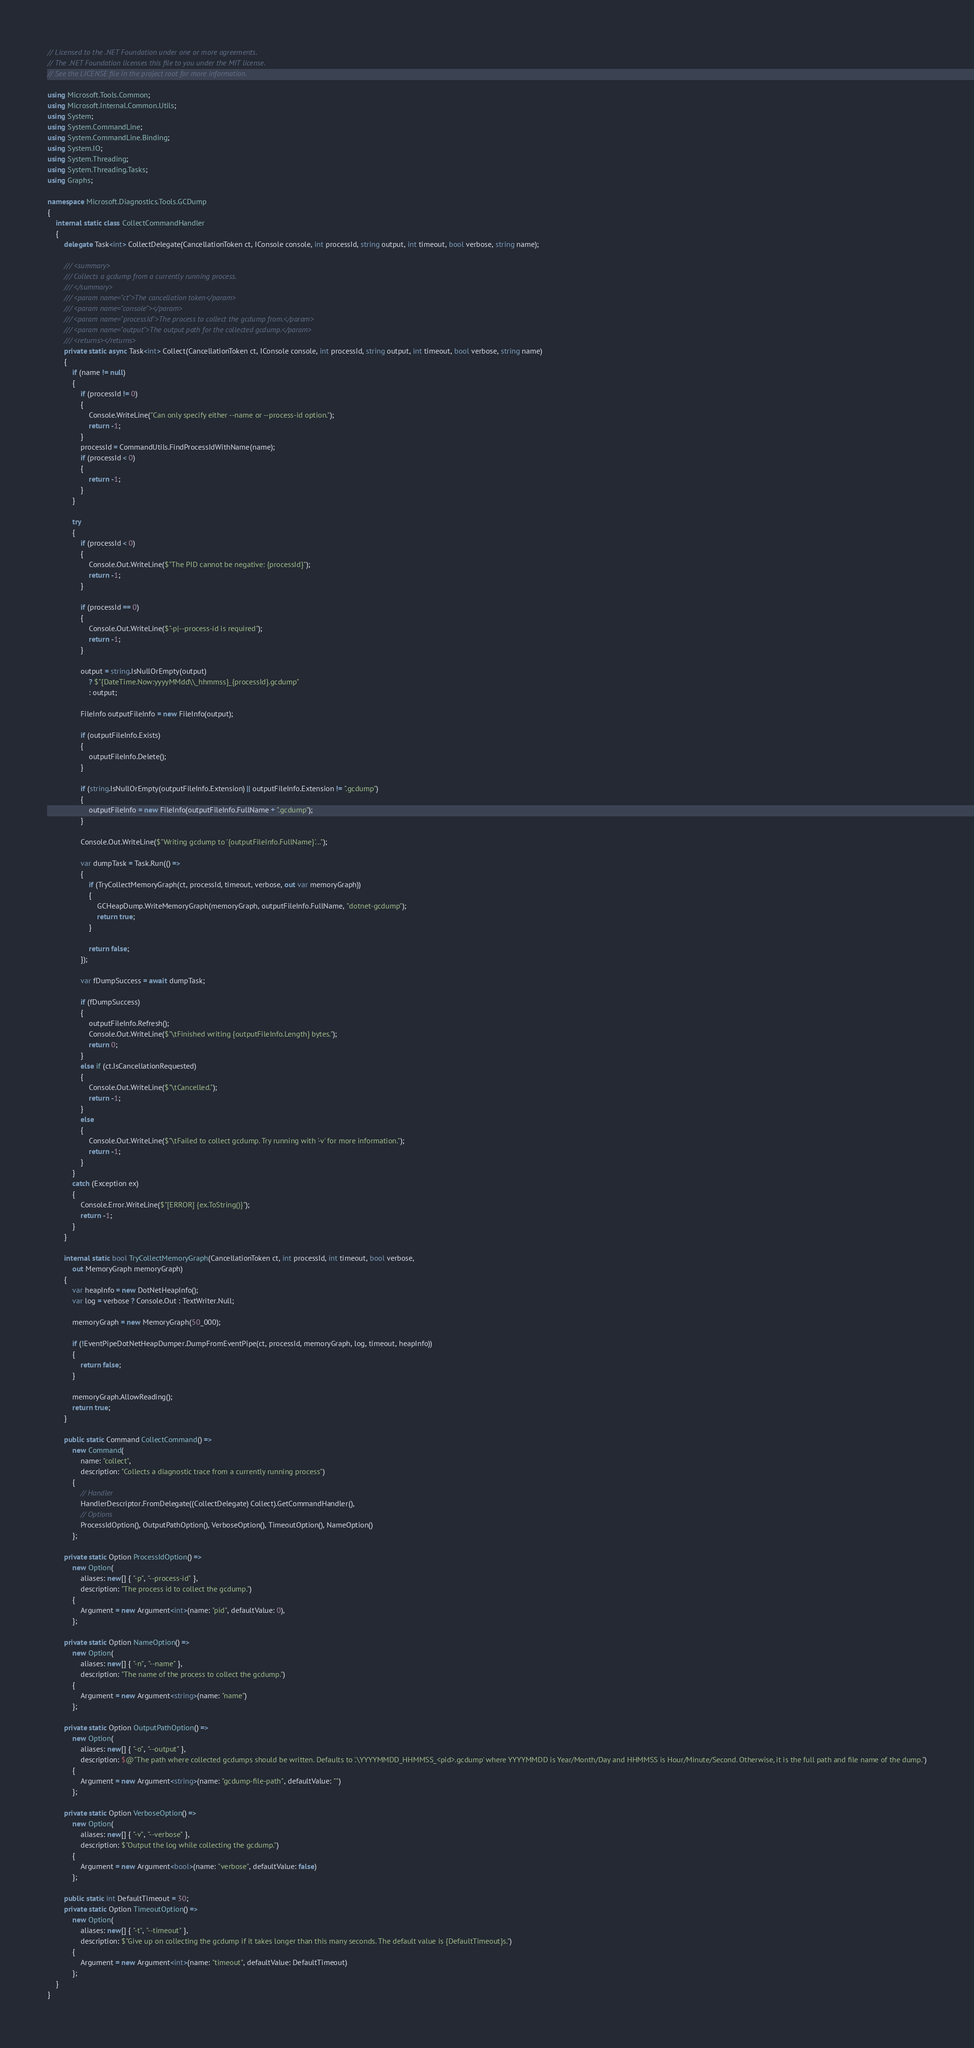<code> <loc_0><loc_0><loc_500><loc_500><_C#_>// Licensed to the .NET Foundation under one or more agreements.
// The .NET Foundation licenses this file to you under the MIT license.
// See the LICENSE file in the project root for more information.

using Microsoft.Tools.Common;
using Microsoft.Internal.Common.Utils;
using System;
using System.CommandLine;
using System.CommandLine.Binding;
using System.IO;
using System.Threading;
using System.Threading.Tasks;
using Graphs;

namespace Microsoft.Diagnostics.Tools.GCDump
{
    internal static class CollectCommandHandler
    {
        delegate Task<int> CollectDelegate(CancellationToken ct, IConsole console, int processId, string output, int timeout, bool verbose, string name);

        /// <summary>
        /// Collects a gcdump from a currently running process.
        /// </summary>
        /// <param name="ct">The cancellation token</param>
        /// <param name="console"></param>
        /// <param name="processId">The process to collect the gcdump from.</param>
        /// <param name="output">The output path for the collected gcdump.</param>
        /// <returns></returns>
        private static async Task<int> Collect(CancellationToken ct, IConsole console, int processId, string output, int timeout, bool verbose, string name)
        {
            if (name != null)
            {
                if (processId != 0)
                {
                    Console.WriteLine("Can only specify either --name or --process-id option.");
                    return -1;
                }
                processId = CommandUtils.FindProcessIdWithName(name);
                if (processId < 0)
                {
                    return -1;
                }
            }

            try
            {
                if (processId < 0)
                {
                    Console.Out.WriteLine($"The PID cannot be negative: {processId}");
                    return -1;
                }

                if (processId == 0)
                {
                    Console.Out.WriteLine($"-p|--process-id is required");
                    return -1;
                }
                
                output = string.IsNullOrEmpty(output)
                    ? $"{DateTime.Now:yyyyMMdd\\_hhmmss}_{processId}.gcdump"
                    : output;

                FileInfo outputFileInfo = new FileInfo(output);

                if (outputFileInfo.Exists)
                {
                    outputFileInfo.Delete();
                }

                if (string.IsNullOrEmpty(outputFileInfo.Extension) || outputFileInfo.Extension != ".gcdump")
                {
                    outputFileInfo = new FileInfo(outputFileInfo.FullName + ".gcdump");
                }
                
                Console.Out.WriteLine($"Writing gcdump to '{outputFileInfo.FullName}'...");

                var dumpTask = Task.Run(() => 
                {
                    if (TryCollectMemoryGraph(ct, processId, timeout, verbose, out var memoryGraph))
                    {
                        GCHeapDump.WriteMemoryGraph(memoryGraph, outputFileInfo.FullName, "dotnet-gcdump");
                        return true;
                    }

                    return false;
                });

                var fDumpSuccess = await dumpTask;

                if (fDumpSuccess)
                {
                    outputFileInfo.Refresh();
                    Console.Out.WriteLine($"\tFinished writing {outputFileInfo.Length} bytes.");
                    return 0;
                }
                else if (ct.IsCancellationRequested)
                {
                    Console.Out.WriteLine($"\tCancelled.");
                    return -1;
                }
                else
                {
                    Console.Out.WriteLine($"\tFailed to collect gcdump. Try running with '-v' for more information.");
                    return -1;
                }
            }
            catch (Exception ex)
            {
                Console.Error.WriteLine($"[ERROR] {ex.ToString()}");
                return -1;
            }
        }

        internal static bool TryCollectMemoryGraph(CancellationToken ct, int processId, int timeout, bool verbose,
            out MemoryGraph memoryGraph)
        {
            var heapInfo = new DotNetHeapInfo();
            var log = verbose ? Console.Out : TextWriter.Null; 
            
            memoryGraph = new MemoryGraph(50_000);

            if (!EventPipeDotNetHeapDumper.DumpFromEventPipe(ct, processId, memoryGraph, log, timeout, heapInfo))
            {
                return false;
            }

            memoryGraph.AllowReading();
            return true;
        }

        public static Command CollectCommand() =>
            new Command(
                name: "collect",
                description: "Collects a diagnostic trace from a currently running process")
            {
                // Handler
                HandlerDescriptor.FromDelegate((CollectDelegate) Collect).GetCommandHandler(),
                // Options
                ProcessIdOption(), OutputPathOption(), VerboseOption(), TimeoutOption(), NameOption()
            };

        private static Option ProcessIdOption() =>
            new Option(
                aliases: new[] { "-p", "--process-id" },
                description: "The process id to collect the gcdump.")
            {
                Argument = new Argument<int>(name: "pid", defaultValue: 0),
            };

        private static Option NameOption() =>
            new Option(
                aliases: new[] { "-n", "--name" },
                description: "The name of the process to collect the gcdump.")
            {
                Argument = new Argument<string>(name: "name")
            };

        private static Option OutputPathOption() =>
            new Option(
                aliases: new[] { "-o", "--output" },
                description: $@"The path where collected gcdumps should be written. Defaults to '.\YYYYMMDD_HHMMSS_<pid>.gcdump' where YYYYMMDD is Year/Month/Day and HHMMSS is Hour/Minute/Second. Otherwise, it is the full path and file name of the dump.")
            {
                Argument = new Argument<string>(name: "gcdump-file-path", defaultValue: "")
            };

        private static Option VerboseOption() =>
            new Option(
                aliases: new[] { "-v", "--verbose" },
                description: $"Output the log while collecting the gcdump.") 
            {
                Argument = new Argument<bool>(name: "verbose", defaultValue: false)
            };

        public static int DefaultTimeout = 30;
        private static Option TimeoutOption() =>
            new Option(
                aliases: new[] { "-t", "--timeout" },
                description: $"Give up on collecting the gcdump if it takes longer than this many seconds. The default value is {DefaultTimeout}s.")
            {
                Argument = new Argument<int>(name: "timeout", defaultValue: DefaultTimeout)
            };
    }
}
</code> 